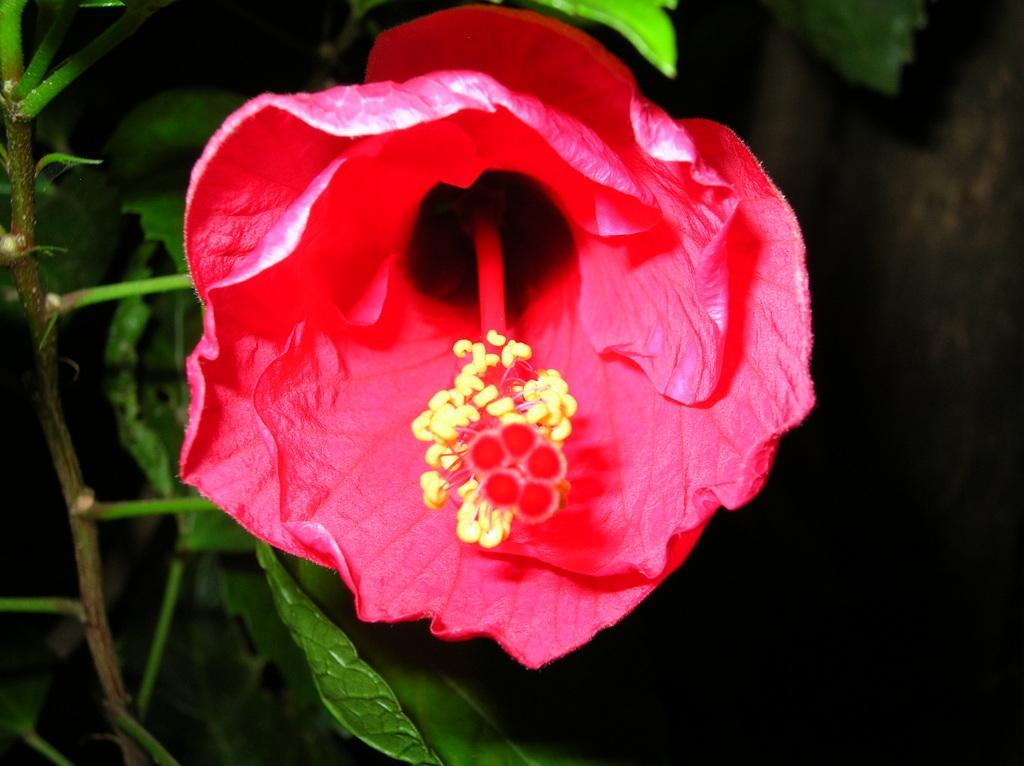Please provide a concise description of this image. In this picture I can see a flower which is of red and yellow in color and I see the leaves on the stem. 